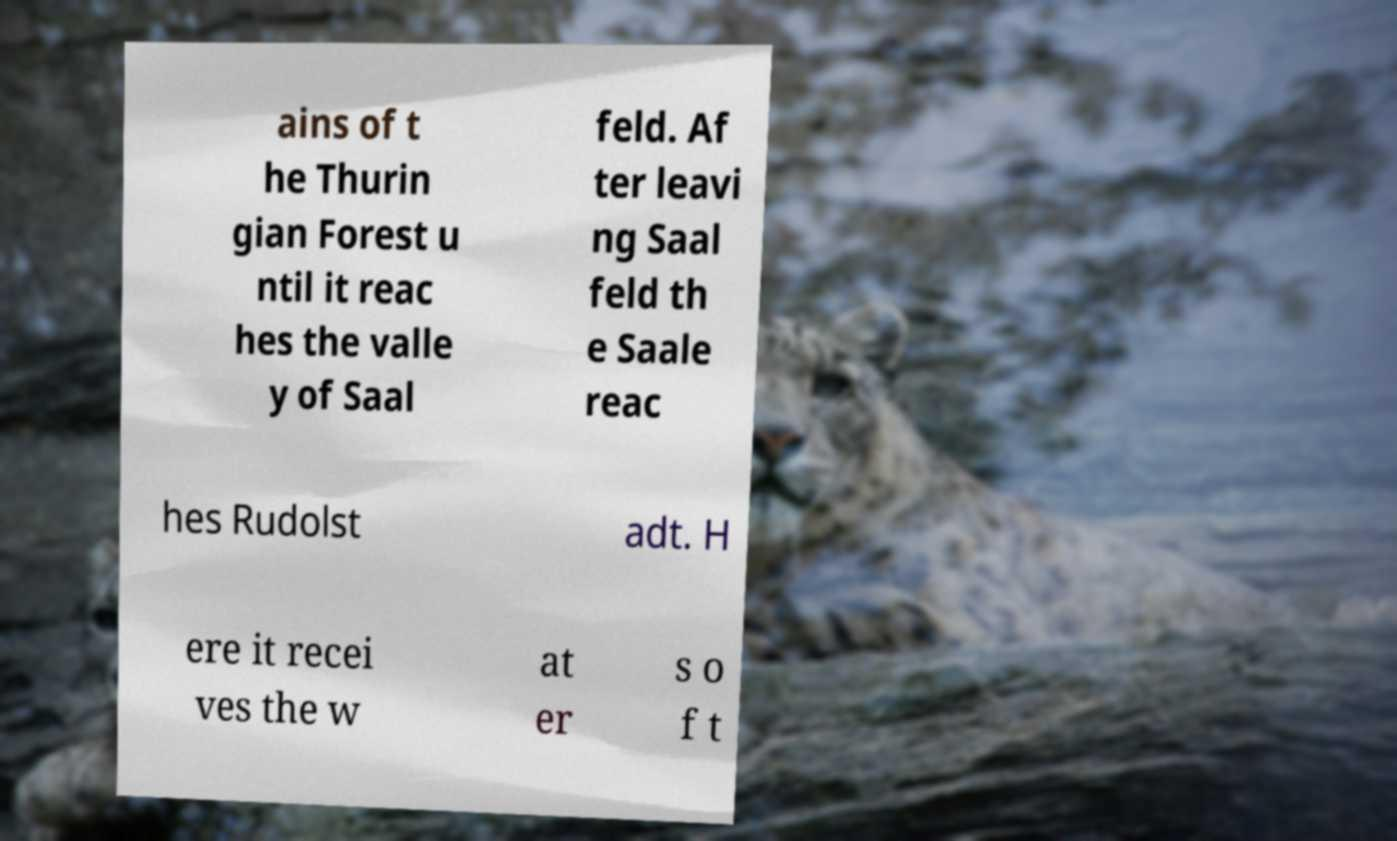Can you accurately transcribe the text from the provided image for me? ains of t he Thurin gian Forest u ntil it reac hes the valle y of Saal feld. Af ter leavi ng Saal feld th e Saale reac hes Rudolst adt. H ere it recei ves the w at er s o f t 